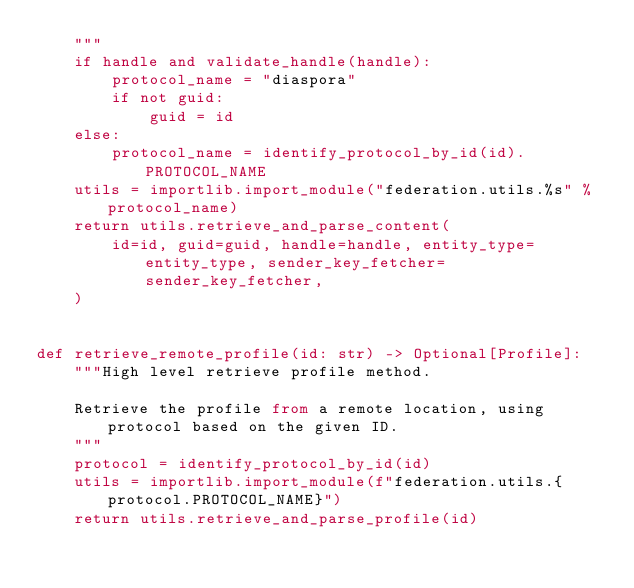Convert code to text. <code><loc_0><loc_0><loc_500><loc_500><_Python_>    """
    if handle and validate_handle(handle):
        protocol_name = "diaspora"
        if not guid:
            guid = id
    else:
        protocol_name = identify_protocol_by_id(id).PROTOCOL_NAME
    utils = importlib.import_module("federation.utils.%s" % protocol_name)
    return utils.retrieve_and_parse_content(
        id=id, guid=guid, handle=handle, entity_type=entity_type, sender_key_fetcher=sender_key_fetcher,
    )


def retrieve_remote_profile(id: str) -> Optional[Profile]:
    """High level retrieve profile method.

    Retrieve the profile from a remote location, using protocol based on the given ID.
    """
    protocol = identify_protocol_by_id(id)
    utils = importlib.import_module(f"federation.utils.{protocol.PROTOCOL_NAME}")
    return utils.retrieve_and_parse_profile(id)
</code> 